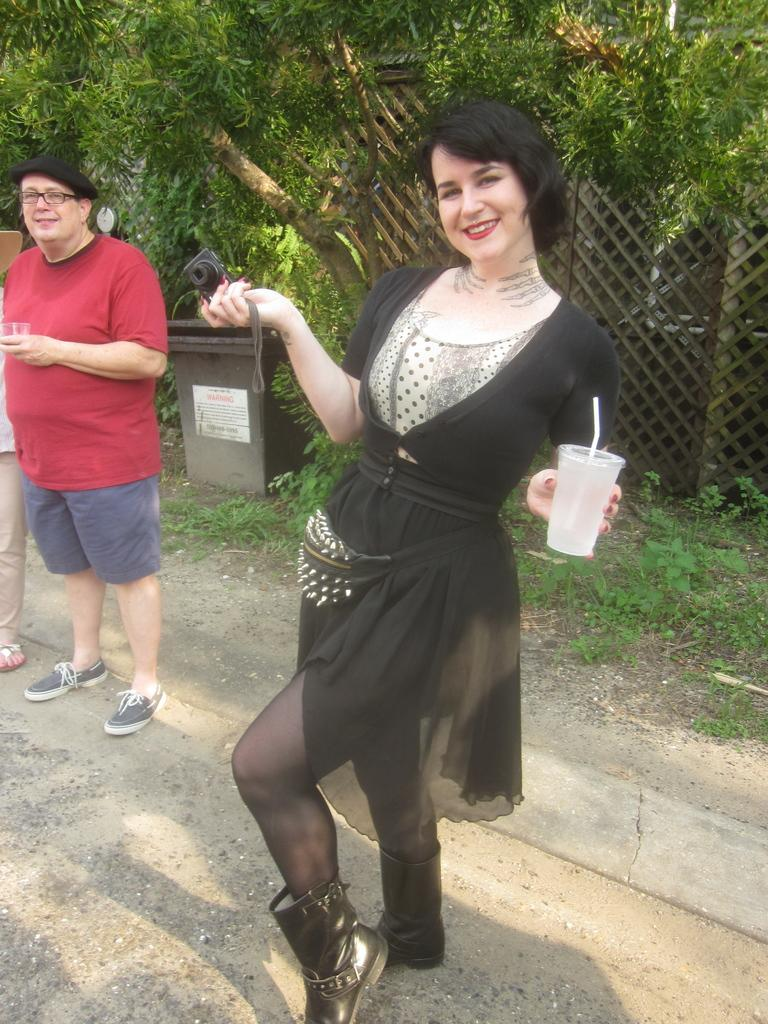What are the people in the image holding? The people are holding disposable tumblers in the image. What is one of the people doing with their hands? One of the people is holding a camera in their hands. What can be seen in the background of the image? In the background of the image, there is a fence, trees, plants, and bins. What type of stocking is being used to crush the cloth in the image? There is no stocking or cloth present in the image. 